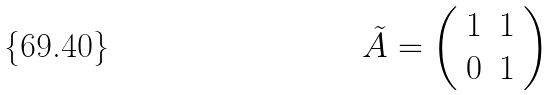Convert formula to latex. <formula><loc_0><loc_0><loc_500><loc_500>\tilde { A } = \left ( \begin{array} { c c } 1 & 1 \\ 0 & 1 \end{array} \right )</formula> 